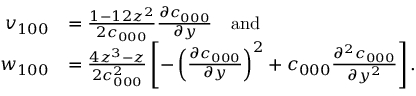Convert formula to latex. <formula><loc_0><loc_0><loc_500><loc_500>\begin{array} { r l } { v _ { 1 0 0 } } & { = \frac { 1 - 1 2 z ^ { 2 } } { 2 c _ { 0 0 0 } } \frac { \partial c _ { 0 0 0 } } { \partial y } \quad a n d } \\ { w _ { 1 0 0 } } & { = \frac { 4 z ^ { 3 } - z } { 2 c _ { 0 0 0 } ^ { 2 } } \left [ - \left ( \frac { \partial c _ { 0 0 0 } } { \partial y } \right ) ^ { 2 } + c _ { 0 0 0 } \frac { \partial ^ { 2 } c _ { 0 0 0 } } { \partial y ^ { 2 } } \right ] . } \end{array}</formula> 